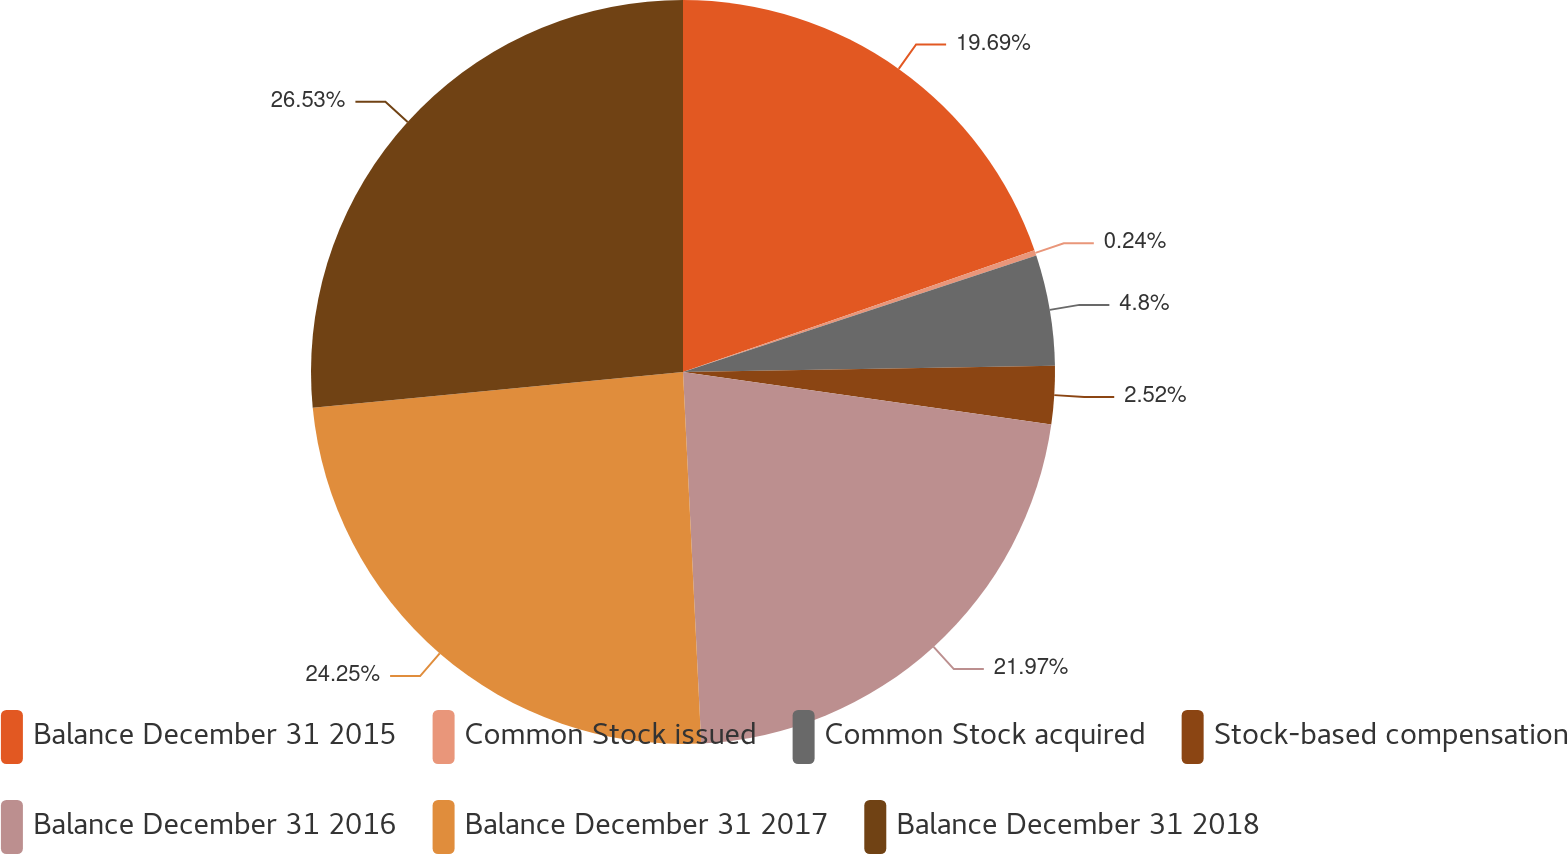<chart> <loc_0><loc_0><loc_500><loc_500><pie_chart><fcel>Balance December 31 2015<fcel>Common Stock issued<fcel>Common Stock acquired<fcel>Stock-based compensation<fcel>Balance December 31 2016<fcel>Balance December 31 2017<fcel>Balance December 31 2018<nl><fcel>19.69%<fcel>0.24%<fcel>4.8%<fcel>2.52%<fcel>21.97%<fcel>24.25%<fcel>26.53%<nl></chart> 